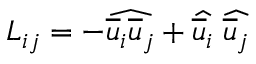<formula> <loc_0><loc_0><loc_500><loc_500>L _ { i j } = - \widehat { \overline { u } _ { i } \overline { u } _ { j } } + \widehat { \overline { u } _ { i } } \, \widehat { \overline { u } _ { j } }</formula> 